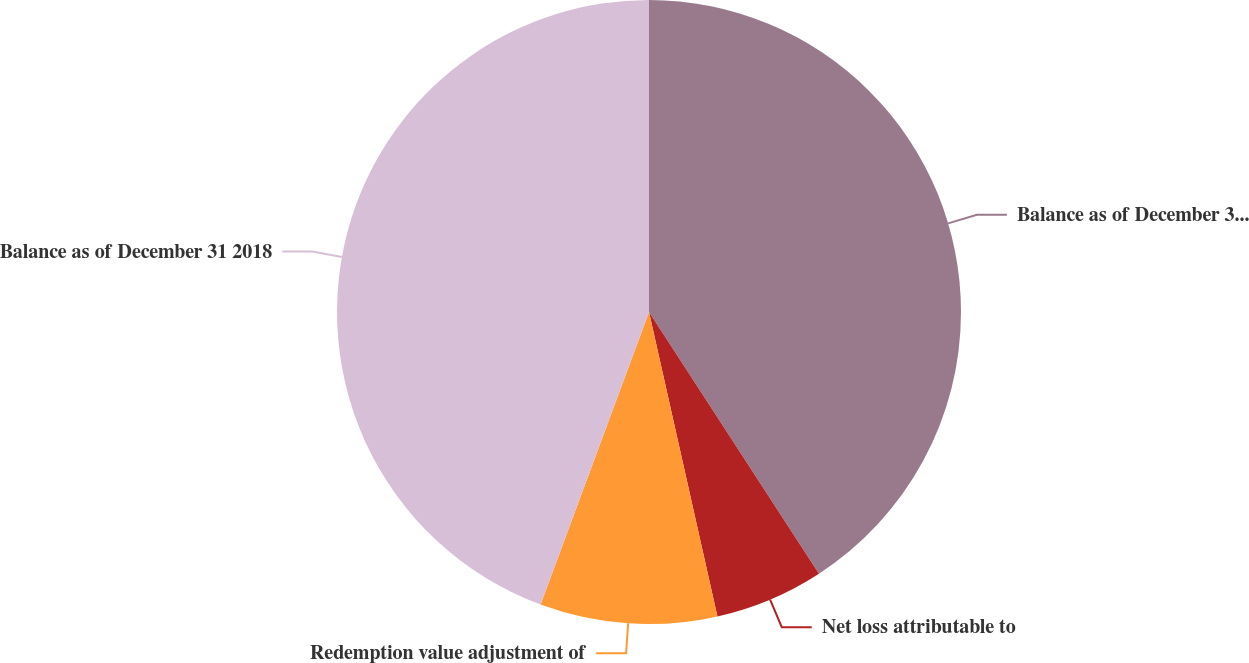Convert chart to OTSL. <chart><loc_0><loc_0><loc_500><loc_500><pie_chart><fcel>Balance as of December 31 2017<fcel>Net loss attributable to<fcel>Redemption value adjustment of<fcel>Balance as of December 31 2018<nl><fcel>40.83%<fcel>5.65%<fcel>9.17%<fcel>44.35%<nl></chart> 